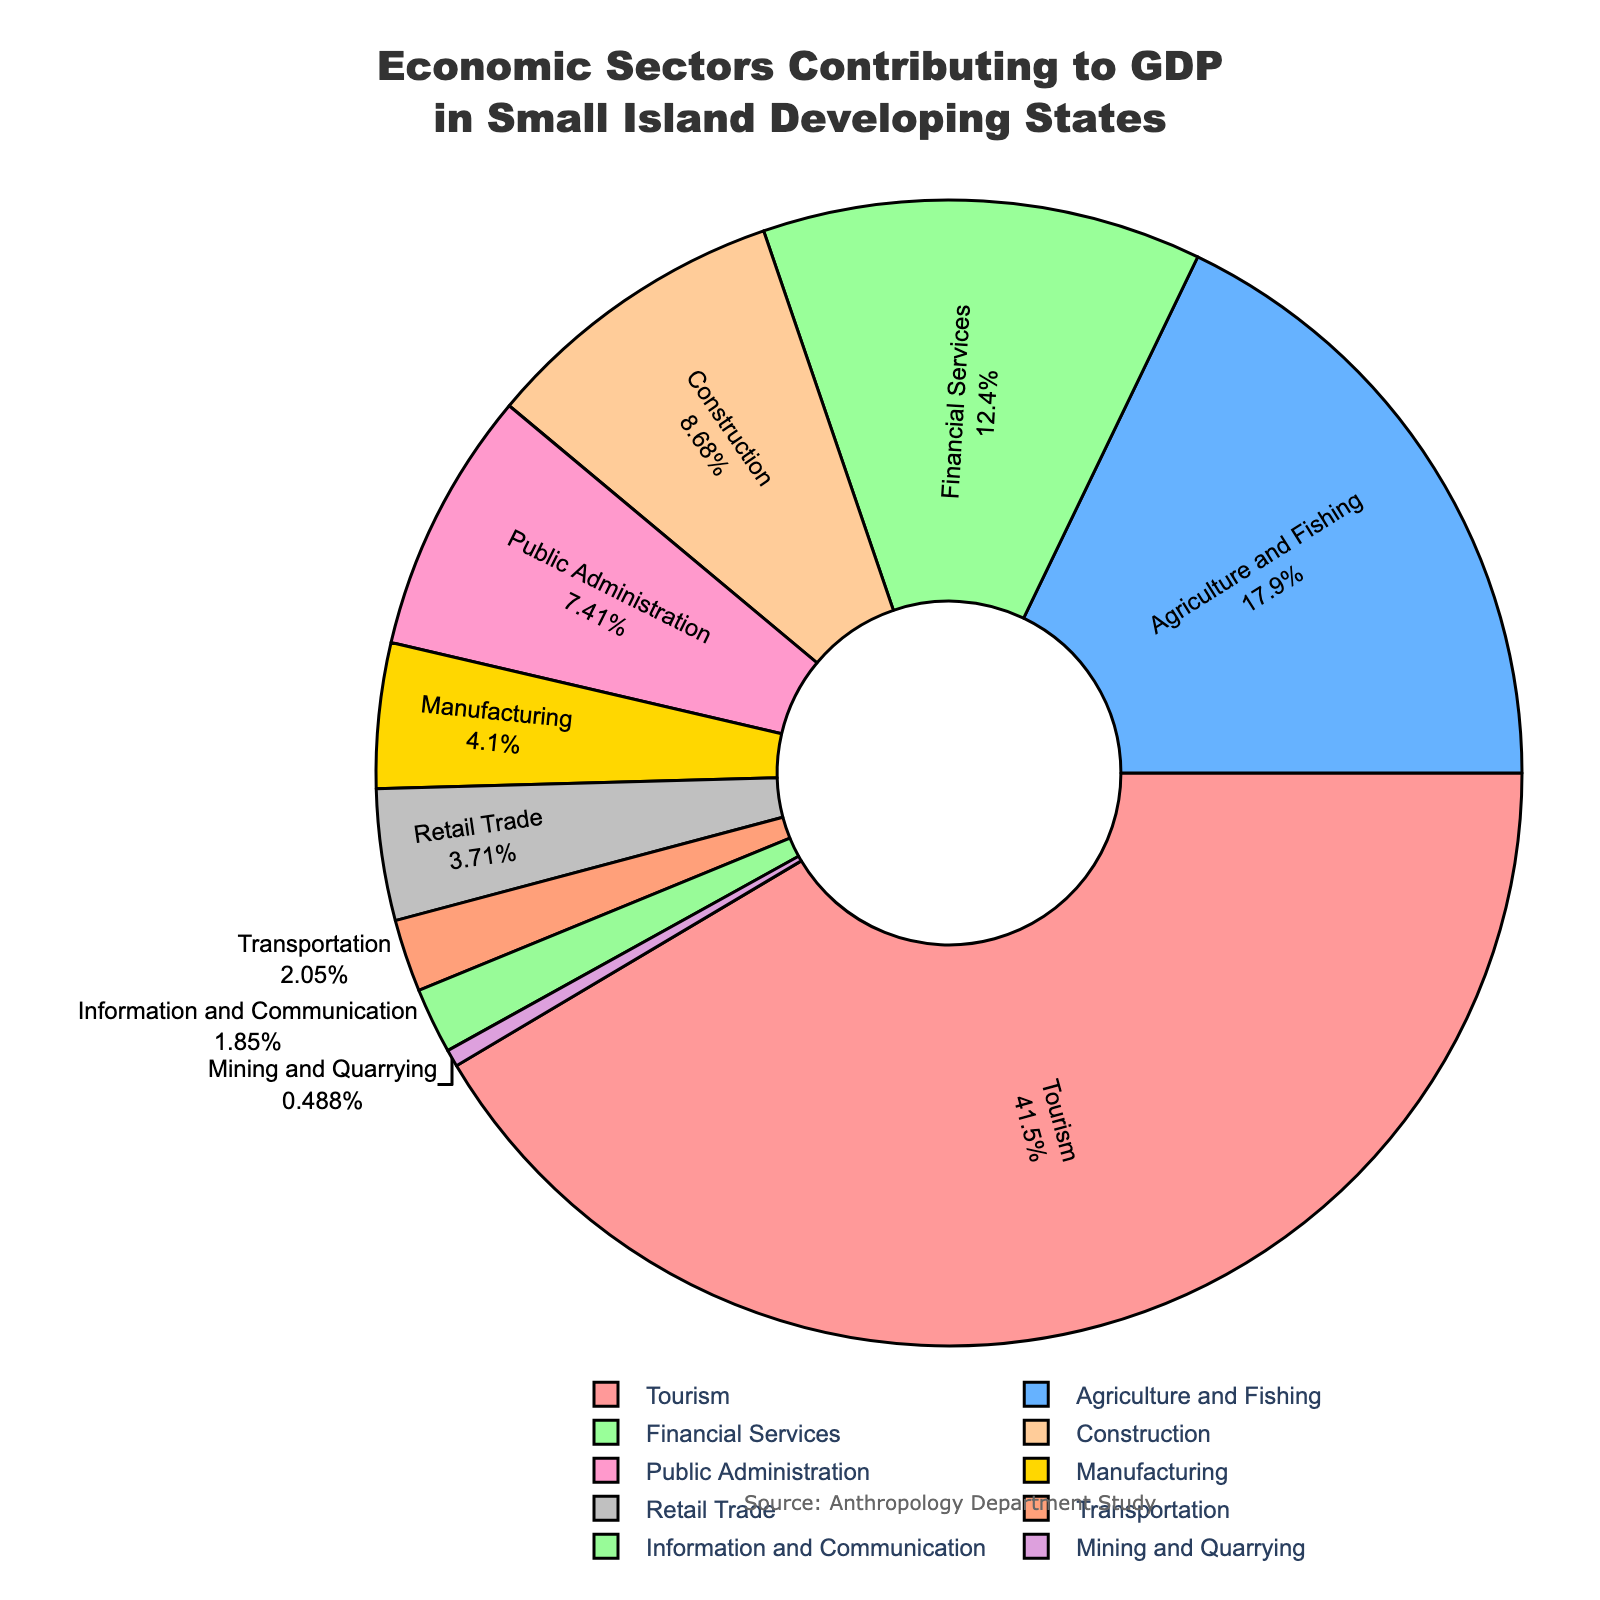What percentage of GDP is contributed by sectors other than Tourism, Agriculture and Fishing, and Financial Services? To find the percentage contributed by all other sectors, subtract the sum of percentages of Tourism, Agriculture and Fishing, and Financial Services from 100%. Sum these three sectors: 42.5 + 18.3 + 12.7 = 73.5%. Then, subtract this from 100%: 100 - 73.5 = 26.5%.
Answer: 26.5% Which two sectors have contributions closest to each other in percentage? By looking at the figure, compare the percent values for all sectors. Public Administration contributes 7.6% and Construction contributes 8.9%, their difference is 1.3%, which is the smallest difference between any pair of sectors.
Answer: Public Administration and Construction What is the least contributing sector to GDP and what is its percentage? From the chart, the smallest section belongs to Mining and Quarrying. It contributes 0.5% to GDP.
Answer: Mining and Quarrying, 0.5% How does the contribution of Manufacturing compare to the contribution of Retail Trade? Refer to the chart: Manufacturing contributes 4.2% and Retail Trade contributes 3.8%. Manufacturing contributes 0.4% more than Retail Trade.
Answer: Manufacturing contributes more What is the combined contribution of Construction and Public Administration to GDP? From the figure, find the percentages of Construction and Public Administration, which are 8.9% and 7.6%, respectively. Add these values: 8.9 + 7.6 = 16.5%.
Answer: 16.5% What sector contributes the most to GDP? The largest section of the pie chart is for Tourism, contributing the highest percentage of 42.5%.
Answer: Tourism Which sector contributes more: Agriculture and Fishing or Financial Services? The pie chart shows Agriculture and Fishing at 18.3% and Financial Services at 12.7%. Agriculture and Fishing contributes more.
Answer: Agriculture and Fishing What is the difference in percentage contribution between Transportation and Information and Communication? Transportation contributes 2.1% and Information and Communication contributes 1.9%. The difference is 2.1 - 1.9 = 0.2%.
Answer: 0.2% If the sum of contributions of Retail Trade, Transportation, Information and Communication, and Mining and Quarrying is X%, what is X? Add the percentages of these sectors: Retail Trade (3.8%), Transportation (2.1%), Information and Communication (1.9%), and Mining and Quarrying (0.5%). Therefore, 3.8 + 2.1 + 1.9 + 0.5 = 8.3%.
Answer: 8.3% What visual characteristic distinguishes sectors contributing over 10% from those under 10%? In the pie chart, larger sections represent sectors over 10% and smaller sections represent those under 10%. Sectors over 10% take up more area visually.
Answer: Larger sections 